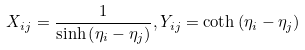Convert formula to latex. <formula><loc_0><loc_0><loc_500><loc_500>X _ { i j } = \frac { 1 } { \sinh \left ( \eta _ { i } - \eta _ { j } \right ) } , Y _ { i j } = \coth \left ( \eta _ { i } - \eta _ { j } \right )</formula> 